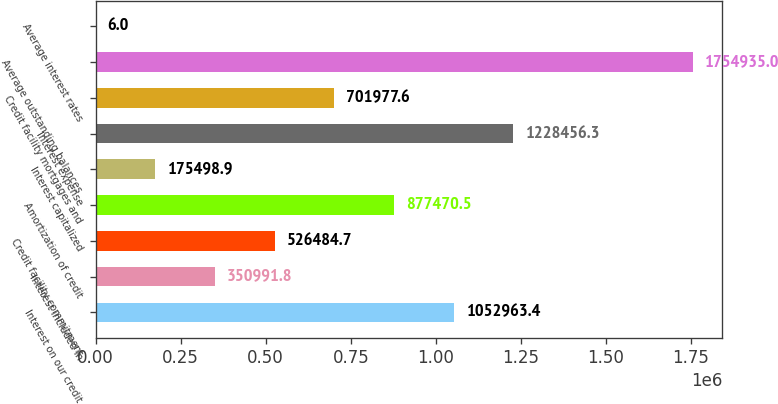<chart> <loc_0><loc_0><loc_500><loc_500><bar_chart><fcel>Interest on our credit<fcel>Interest included in<fcel>Credit facility commitment<fcel>Amortization of credit<fcel>Interest capitalized<fcel>Interest expense<fcel>Credit facility mortgages and<fcel>Average outstanding balances<fcel>Average interest rates<nl><fcel>1.05296e+06<fcel>350992<fcel>526485<fcel>877470<fcel>175499<fcel>1.22846e+06<fcel>701978<fcel>1.75494e+06<fcel>6<nl></chart> 